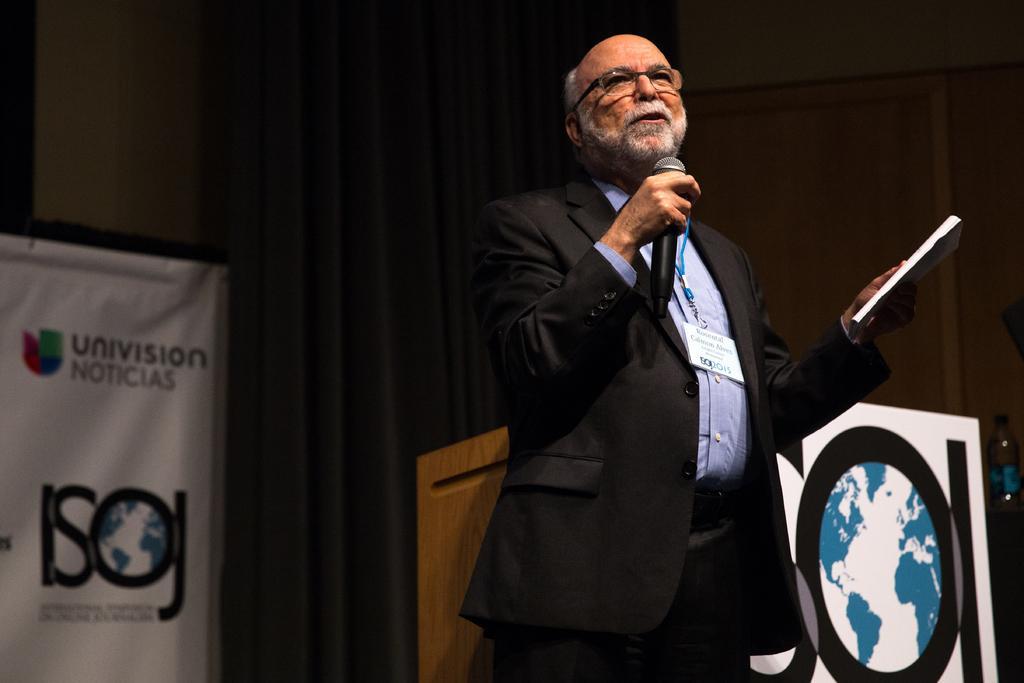Please provide a concise description of this image. In this picture we can see a man who is standing and talking on the mike. He hold a paper with his hand. On the background we can see a banner and this is the podium. 